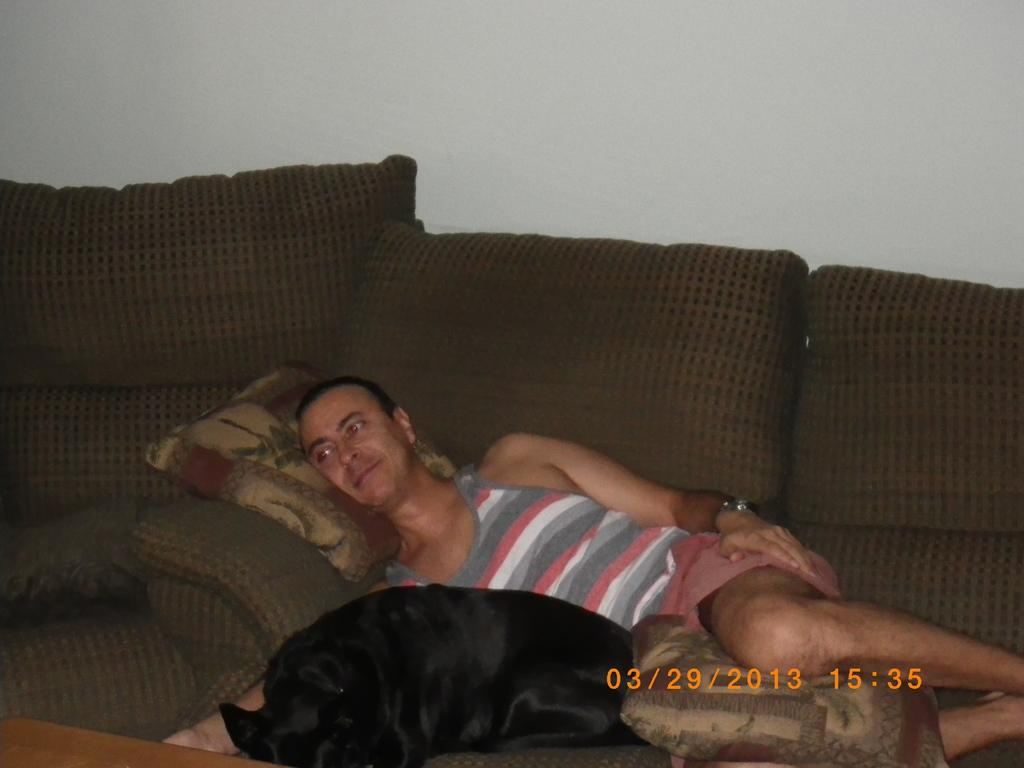What is the man in the image doing? The man is lying on the sofa in the image. What is the man using for support or comfort? The man has a pillow. What animal is beside the man? There is a dog beside the man. What is the color of the dog? The dog is black in color. What can be seen in the background of the image? There is a white wall in the background of the image. How does the man's partner react to the railway passing by during the rainstorm in the image? There is no partner, railway, or rainstorm present in the image. 